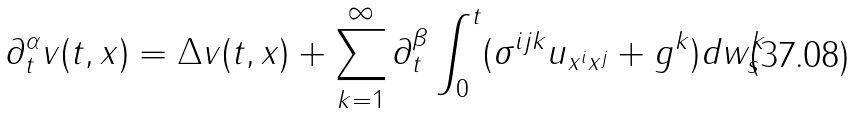<formula> <loc_0><loc_0><loc_500><loc_500>\partial _ { t } ^ { \alpha } v ( t , x ) = \Delta v ( t , x ) + \sum _ { k = 1 } ^ { \infty } \partial _ { t } ^ { \beta } \int _ { 0 } ^ { t } ( \sigma ^ { i j k } u _ { x ^ { i } x ^ { j } } + g ^ { k } ) d w _ { s } ^ { k }</formula> 